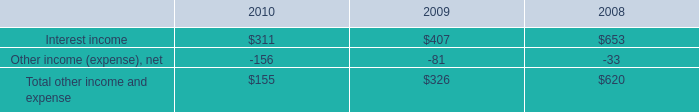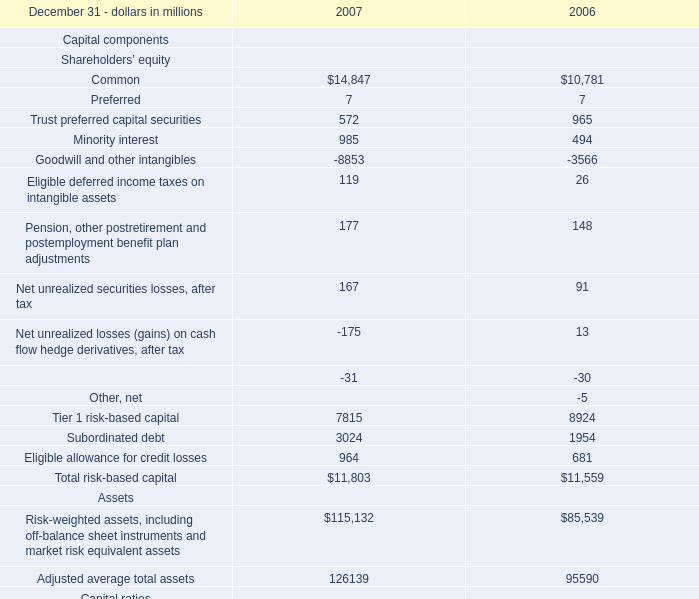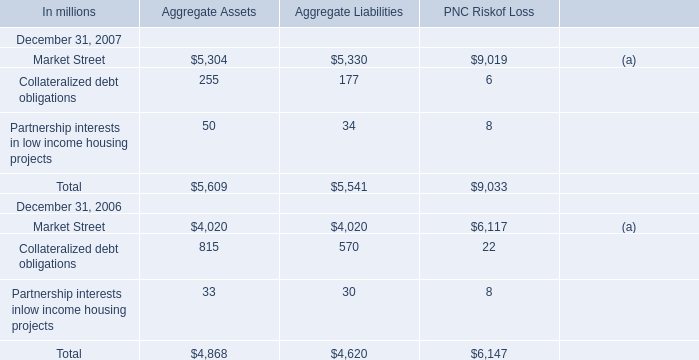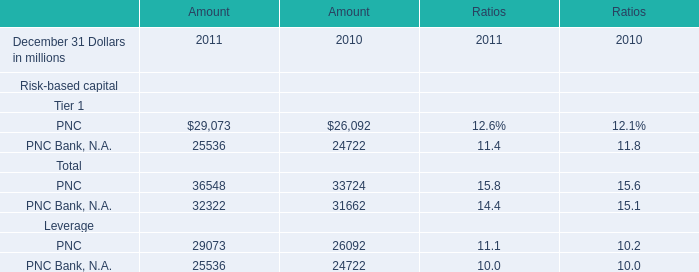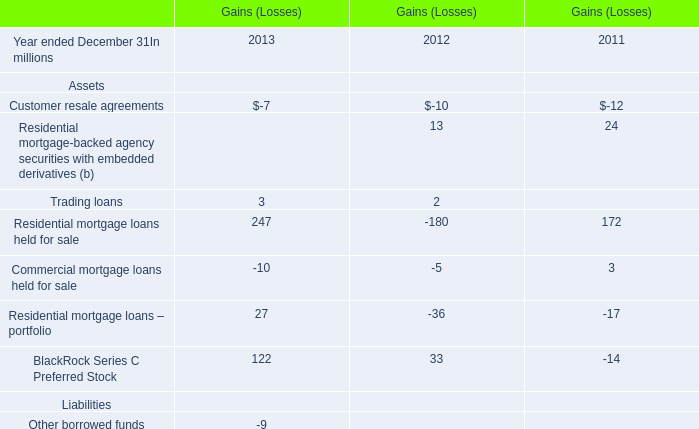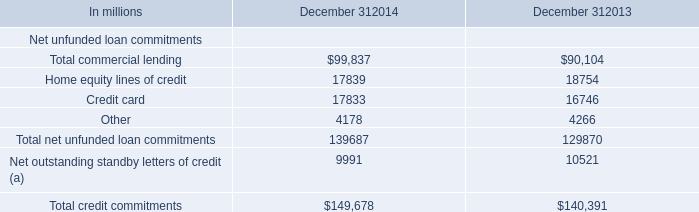What is the value of the Leverage at December 31,2007 as As the chart 1 shows? (in million) 
Answer: 6.2. 